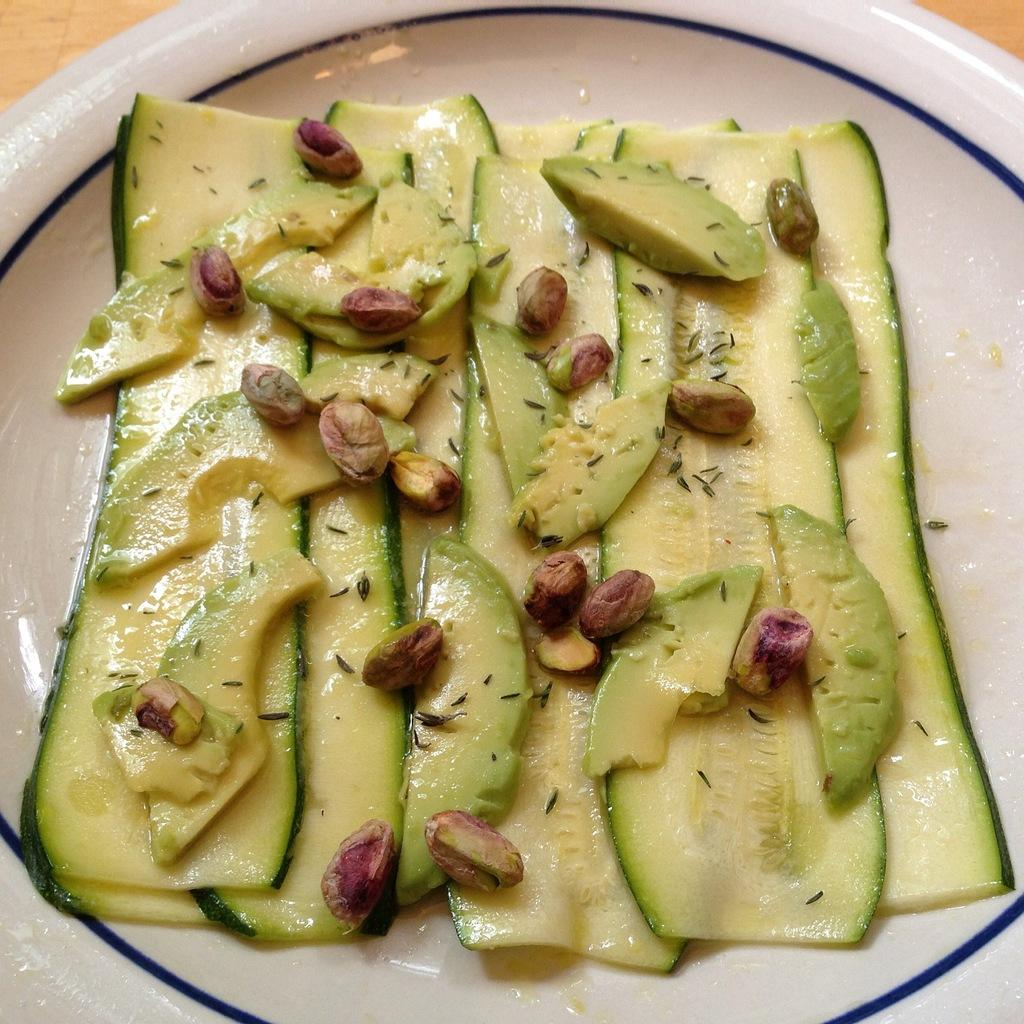What is on the plate that is visible in the image? There are slices of cucumber and avocado on the plate. Are there any other items on the plate besides the cucumber and avocado? Yes, there are pistachio seeds on the plate. How many children are playing with the credit card in the image? There are no children or credit cards present in the image. What type of basin is used to serve the pistachio seeds in the image? There is no basin present in the image; the pistachio seeds are on the plate. 